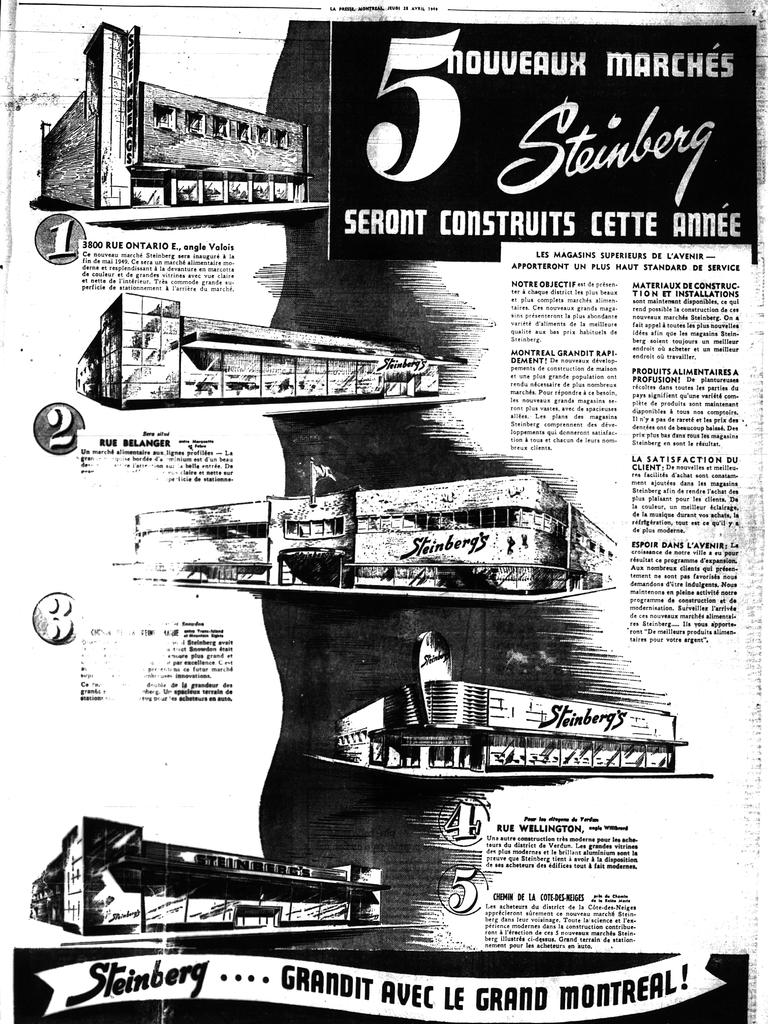<image>
Offer a succinct explanation of the picture presented. a paper with the number 5 on it 